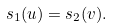Convert formula to latex. <formula><loc_0><loc_0><loc_500><loc_500>s _ { 1 } ( u ) = s _ { 2 } ( v ) .</formula> 